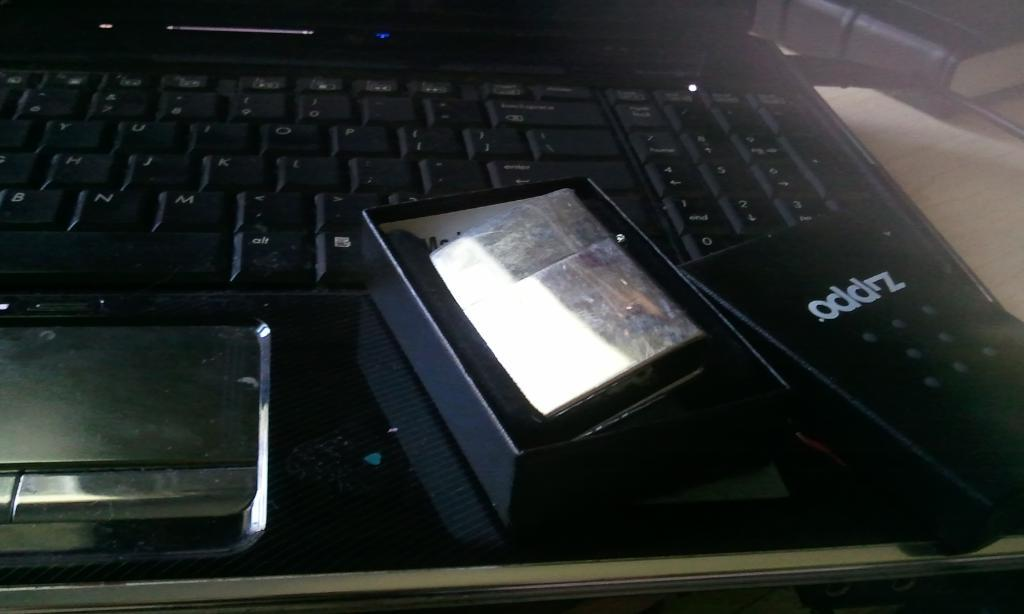Provide a one-sentence caption for the provided image. A black laptop with a box that has oddrz written on it. 